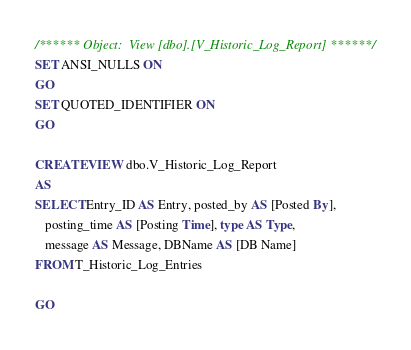<code> <loc_0><loc_0><loc_500><loc_500><_SQL_>/****** Object:  View [dbo].[V_Historic_Log_Report] ******/
SET ANSI_NULLS ON
GO
SET QUOTED_IDENTIFIER ON
GO

CREATE VIEW dbo.V_Historic_Log_Report
AS
SELECT Entry_ID AS Entry, posted_by AS [Posted By], 
   posting_time AS [Posting Time], type AS Type, 
   message AS Message, DBName AS [DB Name]
FROM T_Historic_Log_Entries

GO
</code> 